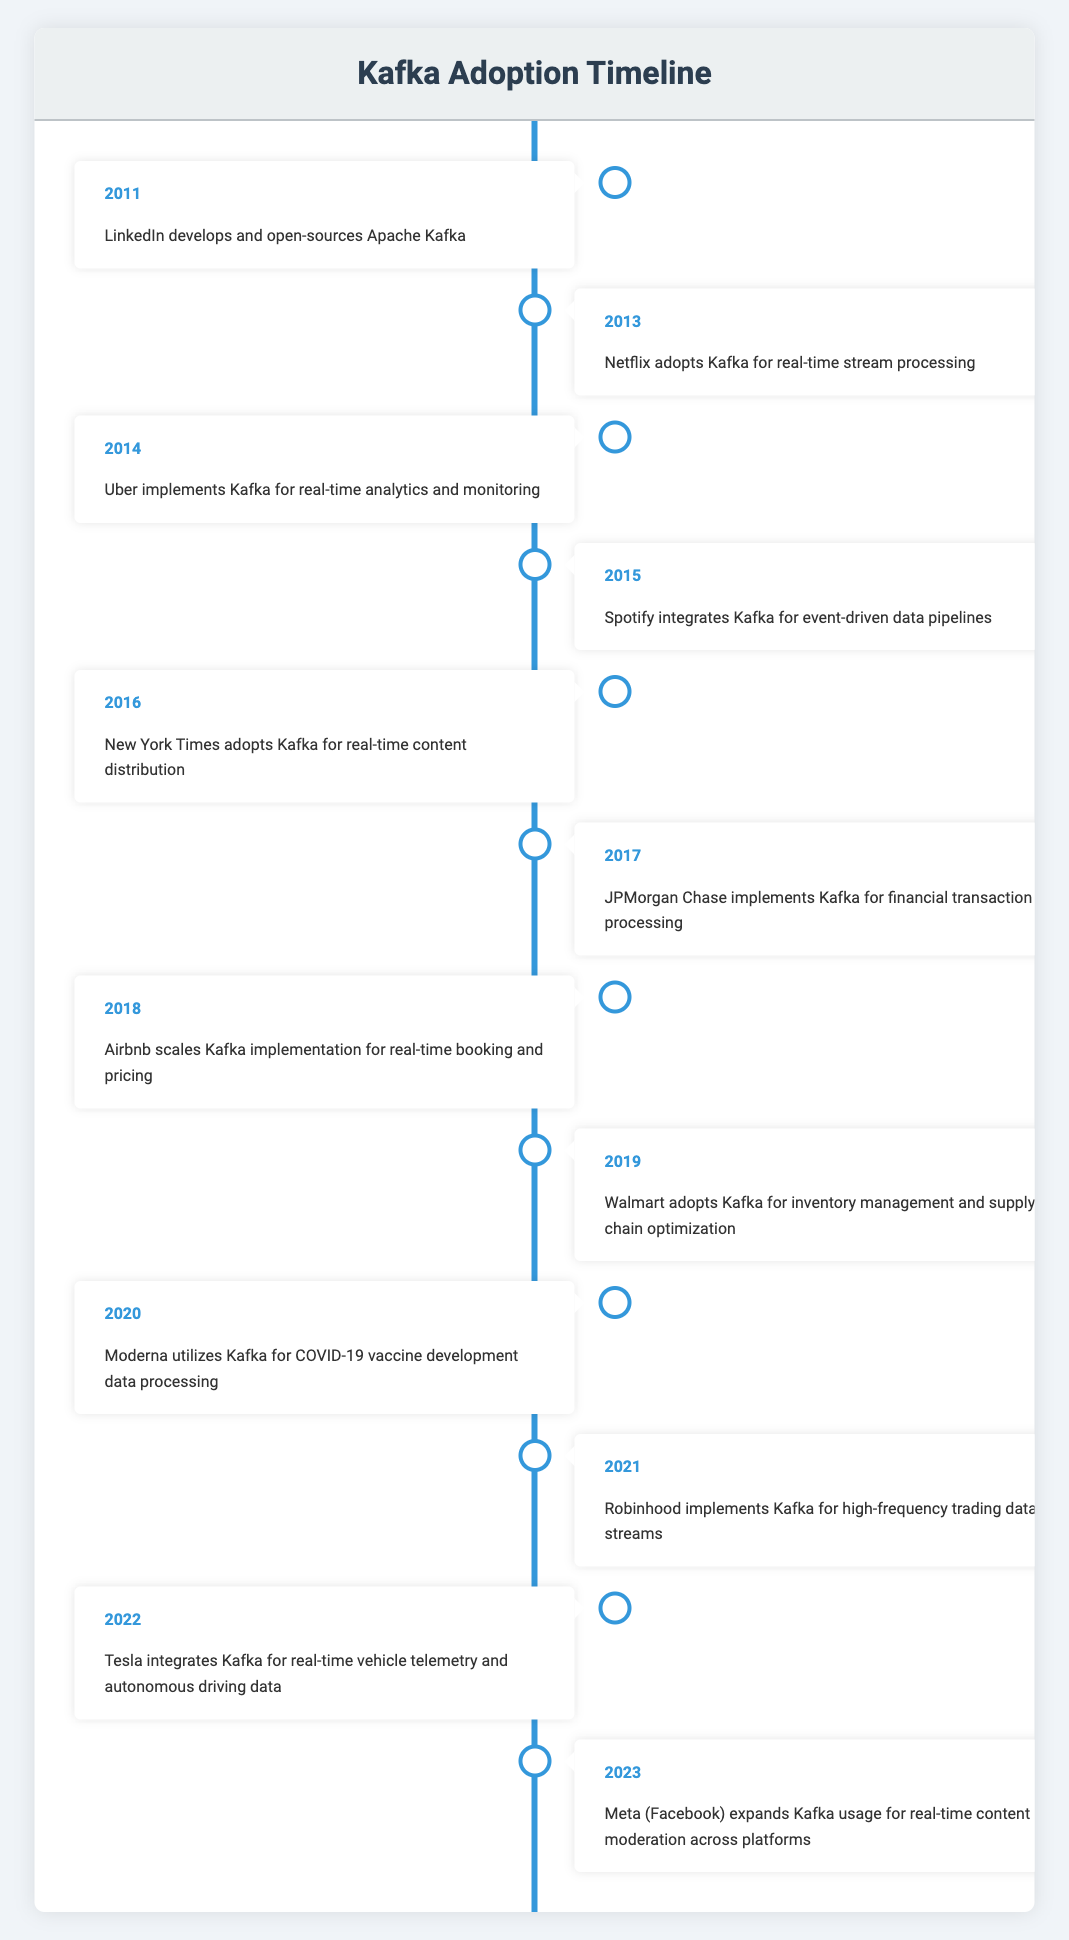What year did LinkedIn develop and open-source Apache Kafka? According to the table, LinkedIn developed and open-sourced Apache Kafka in 2011.
Answer: 2011 What event occurred in the year 2020? The event that occurred in the year 2020, as indicated in the table, was Moderna utilizing Kafka for COVID-19 vaccine development data processing.
Answer: Moderna utilizes Kafka for COVID-19 vaccine development data processing How many organizations have adopted Kafka between 2011 and 2016? By counting the entries from the years 2011 to 2016, there are a total of 6 organizations that adopted Kafka (LinkedIn, Netflix, Uber, Spotify, New York Times, and JPMorgan Chase).
Answer: 6 Did Tesla adopt Kafka before 2022? By looking at the timeline, Tesla adopted Kafka in 2022, so the answer to whether it was adopted before that year is no.
Answer: No What is the difference in years between when Uber and Walmart adopted Kafka? Uber adopted Kafka in 2014 and Walmart adopted it in 2019. The difference is 2019 - 2014 = 5 years.
Answer: 5 Which organization implemented Kafka in 2017? The table states that JPMorgan Chase implemented Kafka in 2017.
Answer: JPMorgan Chase What was the trend of Kafka adoption from 2011 to 2023 in terms of diversity of industries? Analyzing the timeline, early adopters were primarily tech companies like LinkedIn and Netflix, while later years saw adoption across various industries like finance (JPMorgan Chase), healthcare (Moderna), and automotive (Tesla), indicating broadening diversity in applications.
Answer: Increasing diversity across industries Which event happened in the same year as Robinhood's implementation of Kafka? According to the timeline, Robinhood implemented Kafka in 2021, and this was the only event listed for that year.
Answer: N/A Was Kafka utilized for real-time analytics by more than three organizations by 2018? Since organizations like Uber, Airbnb, and JPMorgan Chase were noted for their focus on real-time analytics, the answer is yes.
Answer: Yes 